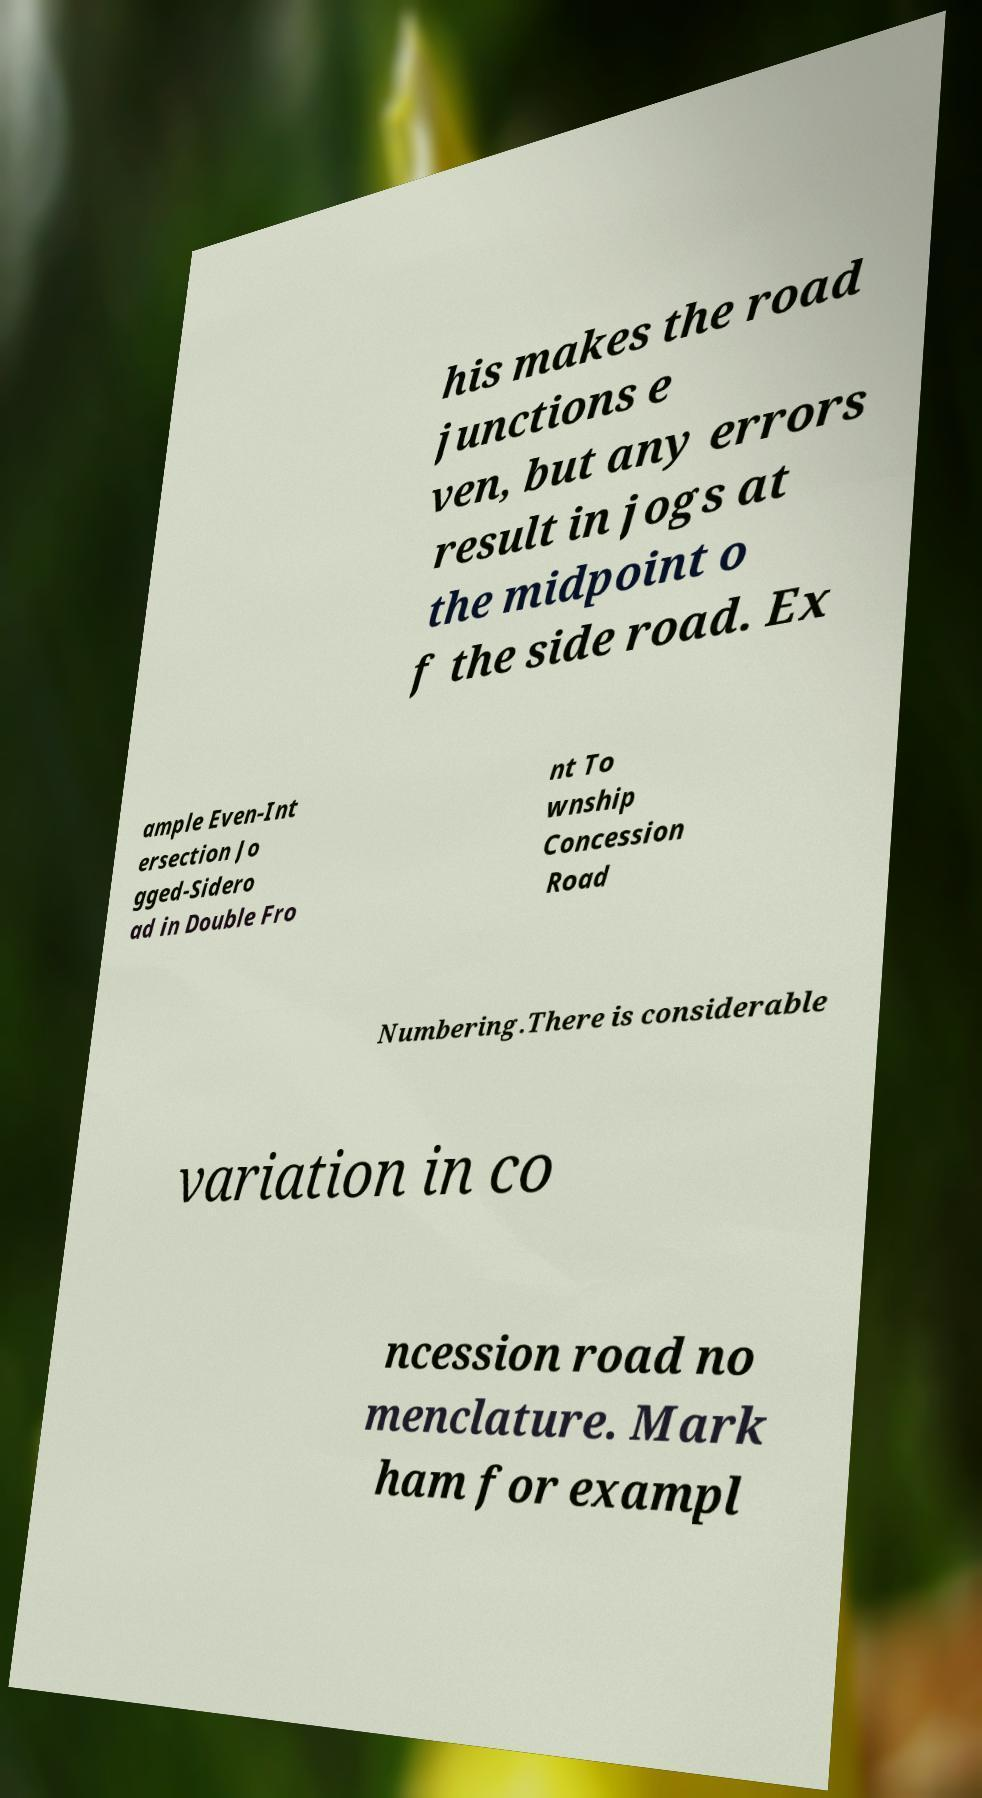Please read and relay the text visible in this image. What does it say? his makes the road junctions e ven, but any errors result in jogs at the midpoint o f the side road. Ex ample Even-Int ersection Jo gged-Sidero ad in Double Fro nt To wnship Concession Road Numbering.There is considerable variation in co ncession road no menclature. Mark ham for exampl 